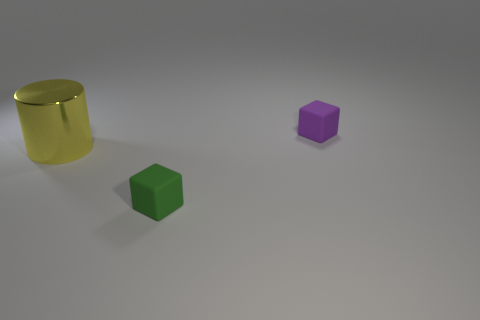Are there any other things that have the same material as the cylinder?
Offer a terse response. No. Is the shape of the small green thing the same as the large object?
Offer a terse response. No. How many big objects are cyan spheres or rubber blocks?
Provide a succinct answer. 0. Are there any big yellow metal things that are in front of the matte object in front of the purple object?
Provide a short and direct response. No. Are any large purple rubber cubes visible?
Provide a succinct answer. No. There is a rubber block left of the small cube that is behind the cylinder; what color is it?
Your answer should be very brief. Green. There is a purple object that is the same shape as the green matte object; what material is it?
Your response must be concise. Rubber. How many green blocks are the same size as the purple cube?
Provide a short and direct response. 1. What size is the purple thing that is the same material as the tiny green cube?
Give a very brief answer. Small. What number of big cyan matte objects are the same shape as the small purple object?
Provide a short and direct response. 0. 